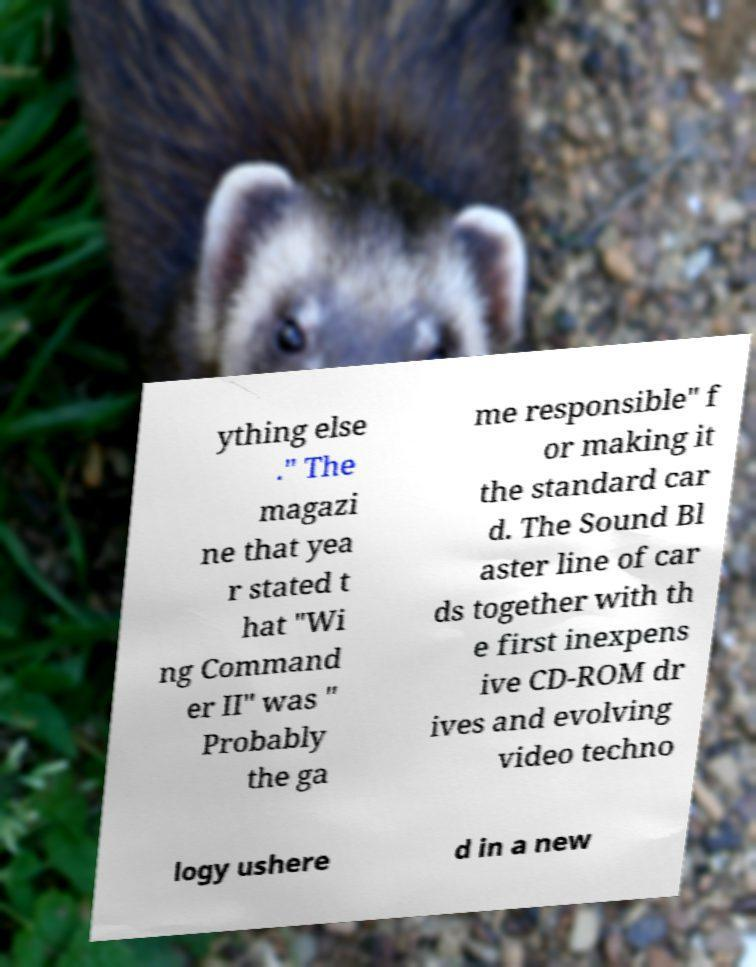I need the written content from this picture converted into text. Can you do that? ything else ." The magazi ne that yea r stated t hat "Wi ng Command er II" was " Probably the ga me responsible" f or making it the standard car d. The Sound Bl aster line of car ds together with th e first inexpens ive CD-ROM dr ives and evolving video techno logy ushere d in a new 